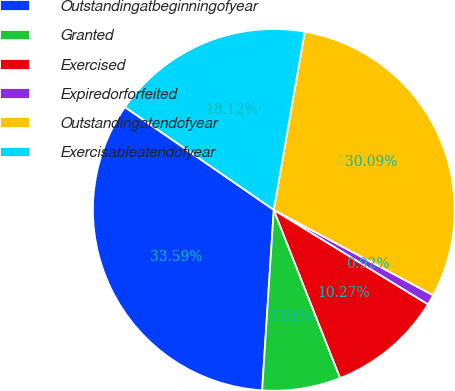Convert chart. <chart><loc_0><loc_0><loc_500><loc_500><pie_chart><fcel>Outstandingatbeginningofyear<fcel>Granted<fcel>Exercised<fcel>Expiredorforfeited<fcel>Outstandingatendofyear<fcel>Exercisableatendofyear<nl><fcel>33.59%<fcel>7.01%<fcel>10.27%<fcel>0.92%<fcel>30.09%<fcel>18.12%<nl></chart> 